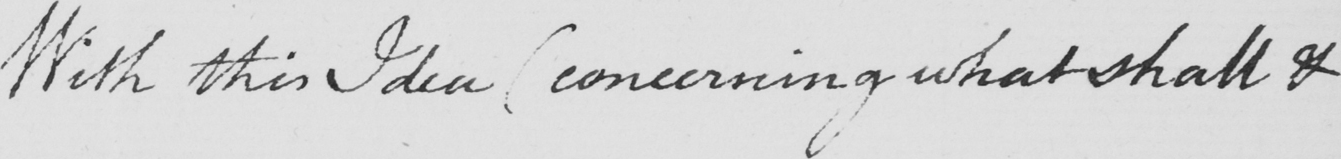Can you tell me what this handwritten text says? With this Idea  ( concerning what shall & 